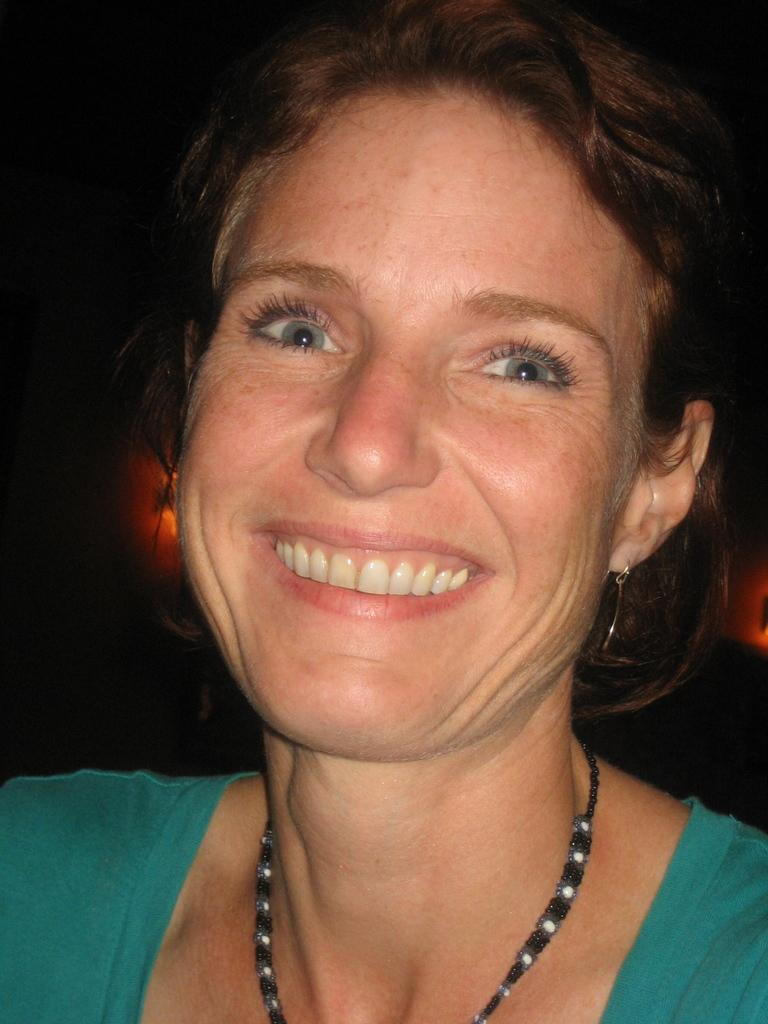What is the main subject in the center of the image? There is a woman in the center of the image. What type of wood is the woman using to create smoke in the image? There is no wood or smoke present in the image; it features a woman in the center. 